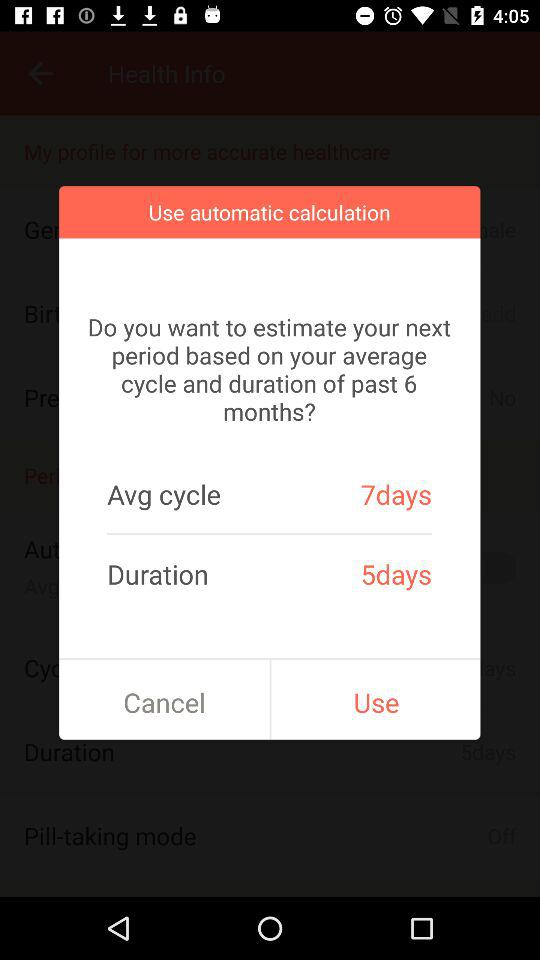How many more days is the average cycle than the duration?
Answer the question using a single word or phrase. 2 